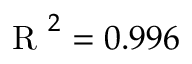<formula> <loc_0><loc_0><loc_500><loc_500>R ^ { 2 } = 0 . 9 9 6</formula> 